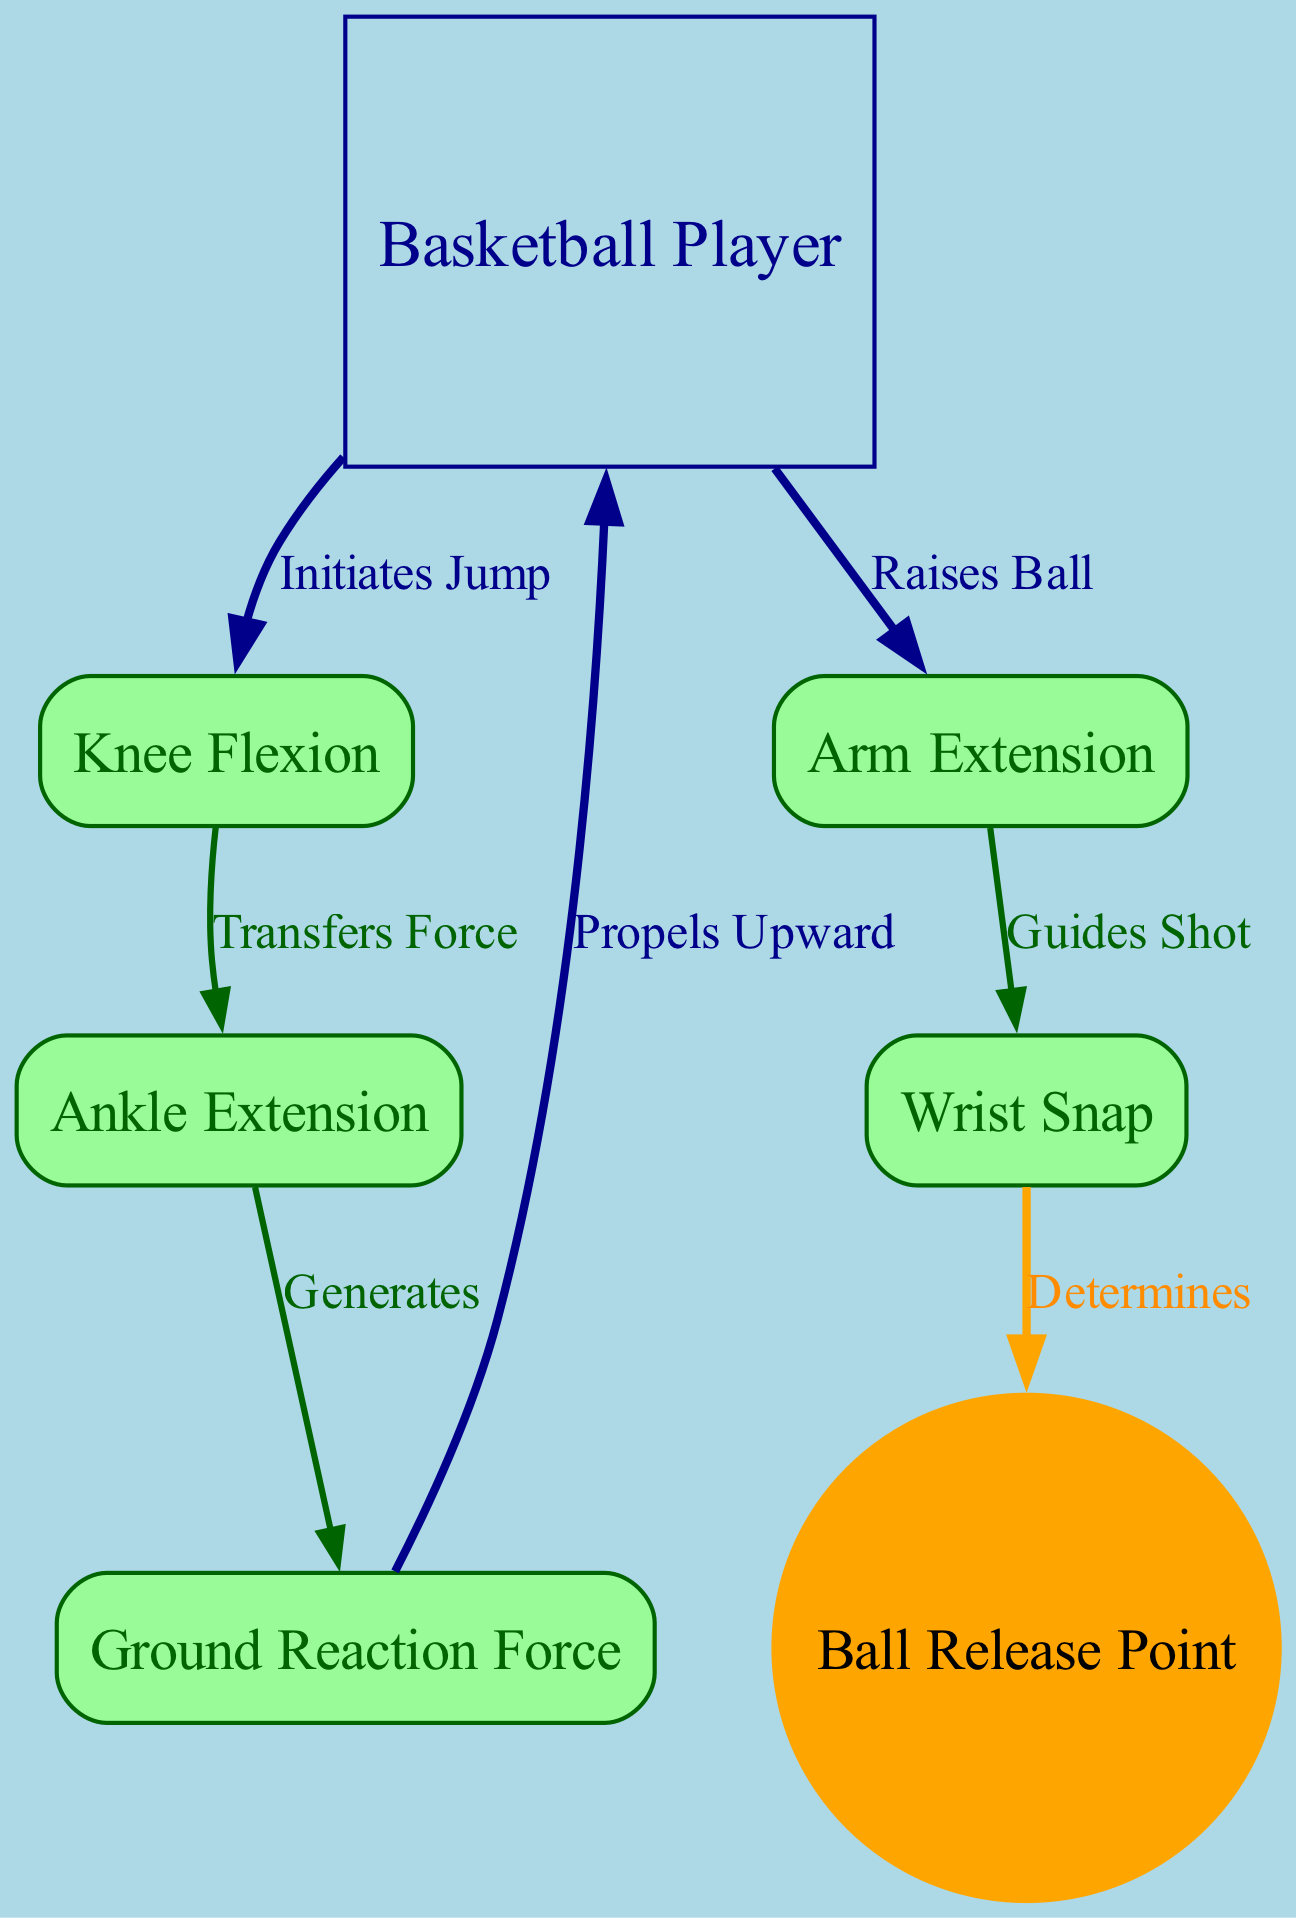What is the first action initiated by the player? The diagram indicates that the player initiates the jump by flexing the knee. Therefore, the first action is represented by the node 'Knee Flexion', which directly follows the player node.
Answer: Knee Flexion How many nodes are present in the diagram? Counting the distinct nodes in the diagram, there are a total of 7 nodes representing different aspects of the jump shot biomechanics.
Answer: 7 What force is generated by ankle extension? According to the diagram's flow, the ankle extension node generates a ground reaction force, which is illustrated in the edge connecting these two nodes.
Answer: Ground Reaction Force What is the final action before the ball is released? The 'Wrist Snap' node is directly linked to the 'Ball Release Point' node in the diagram, indicating that this action is performed just before releasing the ball.
Answer: Wrist Snap Which body part raises the ball? The diagram explicitly shows that after the player initiates the jump, the arm extension occurs, which is responsible for raising the ball during the shot.
Answer: Arm Extension What does the ground force do in the context of the jump shot? From the diagram, the ground force is shown to propel the player upward, indicating its role in lifting the player off the ground during the jump.
Answer: Propels Upward What action follows knee flexion in the diagram? The diagram outlines a sequence of actions where the knee flexion transfers force to the ankle extension, linking these two key parts of the jump biomechanics.
Answer: Transfers Force What shape is used to represent the player in the diagram? The player is represented using a person shape in the diagram, which visually distinguishes this node from others that have different shapes.
Answer: Person 